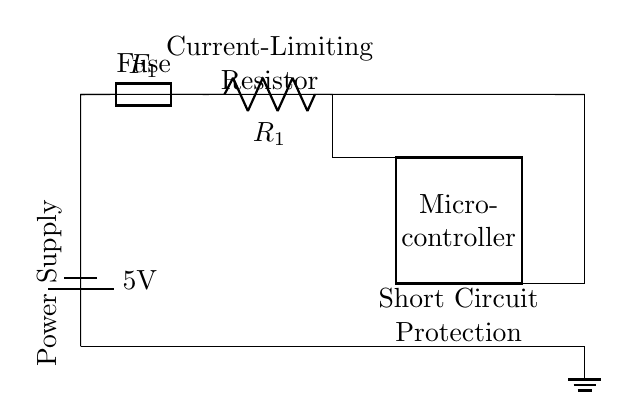What is the type of power supply used in the circuit? The circuit diagram shows a battery labeled 5V, which indicates that the power supply is a DC battery.
Answer: Battery What component provides short circuit protection? The fuse, labeled as F1, is the component that provides short circuit protection by breaking the circuit if the current exceeds a certain threshold.
Answer: Fuse What is the purpose of the current-limiting resistor? The current-limiting resistor, labeled R1, is used to limit the amount of current flowing to the microcontroller, ensuring it operates within safe limits.
Answer: Current limiting How many components are connected in series in the circuit? The fuse, current-limiting resistor, and microcontroller are connected in series, resulting in a total of three components in this configuration.
Answer: Three What component can be replaced if it blows due to a short circuit? The fuse F1 can be replaced if it blows due to a short circuit, as it is designed to protect the circuit by breaking the connection.
Answer: Fuse What is the voltage rating supplied to the microcontroller? The microcontroller is supplied with a voltage of 5V from the power supply.
Answer: 5V 